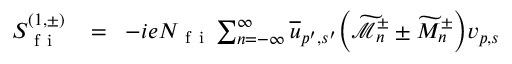<formula> <loc_0><loc_0><loc_500><loc_500>\begin{array} { r l r } { S _ { f i } ^ { ( 1 , \pm ) } \, } & = } & { \, - i e N _ { f i } \sum _ { n = - \infty } ^ { \infty } \overline { u } _ { p ^ { \prime } , s ^ { \prime } } \left ( \widetilde { \mathcal { M } } _ { n } ^ { \pm } \pm \widetilde { M } _ { n } ^ { \pm } \right ) v _ { p , s } } \end{array}</formula> 